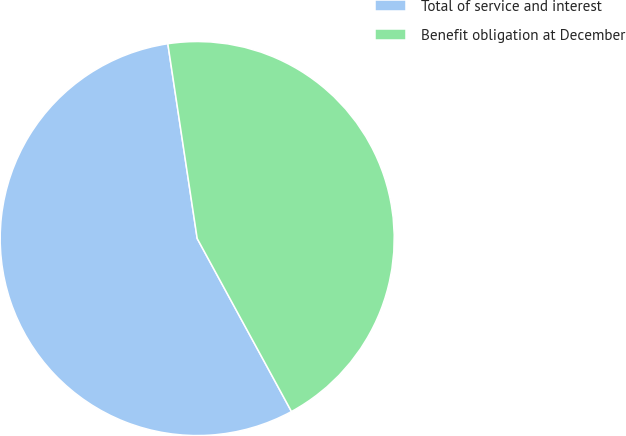<chart> <loc_0><loc_0><loc_500><loc_500><pie_chart><fcel>Total of service and interest<fcel>Benefit obligation at December<nl><fcel>55.56%<fcel>44.44%<nl></chart> 